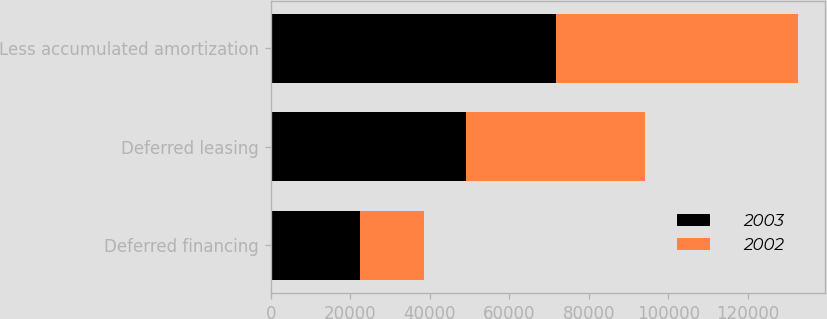<chart> <loc_0><loc_0><loc_500><loc_500><stacked_bar_chart><ecel><fcel>Deferred financing<fcel>Deferred leasing<fcel>Less accumulated amortization<nl><fcel>2003<fcel>22464<fcel>49131<fcel>71595<nl><fcel>2002<fcel>16180<fcel>44881<fcel>61061<nl></chart> 